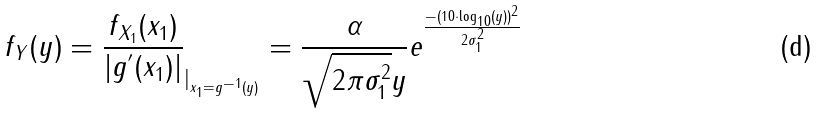<formula> <loc_0><loc_0><loc_500><loc_500>f _ { Y } ( y ) = \frac { f _ { X _ { 1 } } ( x _ { 1 } ) } { | g ^ { ^ { \prime } } ( x _ { 1 } ) | } _ { | _ { x _ { 1 } = g ^ { - 1 } ( y ) } } = \frac { \alpha } { \sqrt { 2 \pi \sigma _ { 1 } ^ { 2 } } y } e ^ { \frac { - ( 1 0 \cdot \log _ { 1 0 } ( y ) ) ^ { 2 } } { 2 \sigma _ { 1 } ^ { 2 } } }</formula> 